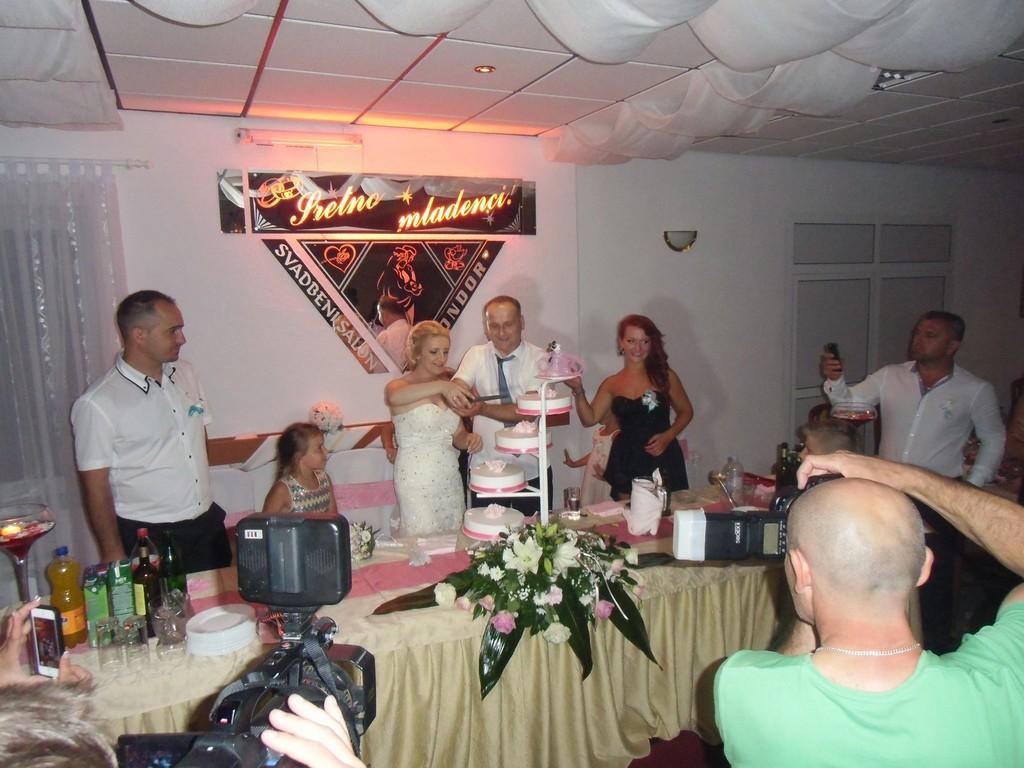In one or two sentences, can you explain what this image depicts? In this image there is a woman and a man cutting a cake in front of them on a table, on the table there are some other objects, besides the couple there are a few people standing and clicking pictures, in front of the image there is a person holding a camera and clicking pictures, beside him there is another person holding a camera and taking a video, in the background of the image on the wall there are decorative banners, curtains on the windows and a lamp. At the top of the image there is fall ceiling. 